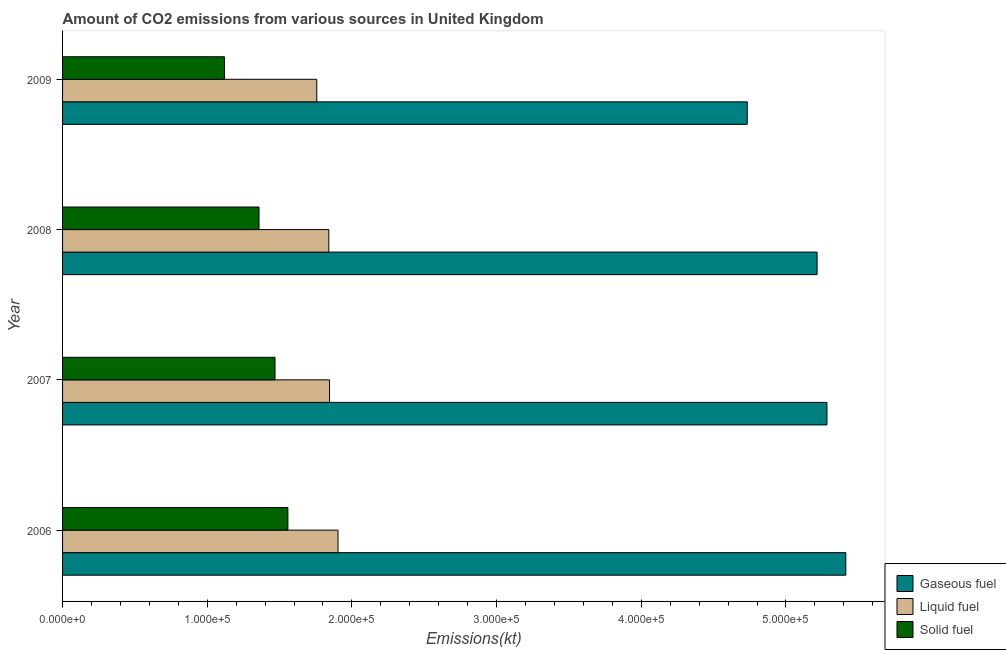How many bars are there on the 2nd tick from the top?
Give a very brief answer. 3. What is the label of the 1st group of bars from the top?
Your answer should be compact. 2009. In how many cases, is the number of bars for a given year not equal to the number of legend labels?
Ensure brevity in your answer.  0. What is the amount of co2 emissions from solid fuel in 2006?
Your answer should be compact. 1.56e+05. Across all years, what is the maximum amount of co2 emissions from gaseous fuel?
Offer a very short reply. 5.41e+05. Across all years, what is the minimum amount of co2 emissions from solid fuel?
Your answer should be compact. 1.12e+05. In which year was the amount of co2 emissions from solid fuel maximum?
Provide a succinct answer. 2006. What is the total amount of co2 emissions from gaseous fuel in the graph?
Provide a short and direct response. 2.06e+06. What is the difference between the amount of co2 emissions from liquid fuel in 2006 and that in 2007?
Your response must be concise. 5859.87. What is the difference between the amount of co2 emissions from gaseous fuel in 2006 and the amount of co2 emissions from liquid fuel in 2008?
Your answer should be very brief. 3.57e+05. What is the average amount of co2 emissions from solid fuel per year?
Your answer should be very brief. 1.38e+05. In the year 2007, what is the difference between the amount of co2 emissions from gaseous fuel and amount of co2 emissions from liquid fuel?
Make the answer very short. 3.44e+05. In how many years, is the amount of co2 emissions from gaseous fuel greater than 40000 kt?
Provide a succinct answer. 4. What is the ratio of the amount of co2 emissions from solid fuel in 2007 to that in 2009?
Offer a terse response. 1.31. Is the difference between the amount of co2 emissions from gaseous fuel in 2006 and 2007 greater than the difference between the amount of co2 emissions from liquid fuel in 2006 and 2007?
Keep it short and to the point. Yes. What is the difference between the highest and the second highest amount of co2 emissions from liquid fuel?
Your answer should be very brief. 5859.87. What is the difference between the highest and the lowest amount of co2 emissions from liquid fuel?
Make the answer very short. 1.47e+04. What does the 1st bar from the top in 2007 represents?
Give a very brief answer. Solid fuel. What does the 2nd bar from the bottom in 2008 represents?
Provide a short and direct response. Liquid fuel. Is it the case that in every year, the sum of the amount of co2 emissions from gaseous fuel and amount of co2 emissions from liquid fuel is greater than the amount of co2 emissions from solid fuel?
Provide a short and direct response. Yes. How many bars are there?
Make the answer very short. 12. How many years are there in the graph?
Your response must be concise. 4. Are the values on the major ticks of X-axis written in scientific E-notation?
Provide a succinct answer. Yes. Does the graph contain any zero values?
Offer a terse response. No. Where does the legend appear in the graph?
Give a very brief answer. Bottom right. What is the title of the graph?
Give a very brief answer. Amount of CO2 emissions from various sources in United Kingdom. Does "Ages 65 and above" appear as one of the legend labels in the graph?
Ensure brevity in your answer.  No. What is the label or title of the X-axis?
Offer a terse response. Emissions(kt). What is the label or title of the Y-axis?
Offer a very short reply. Year. What is the Emissions(kt) in Gaseous fuel in 2006?
Provide a short and direct response. 5.41e+05. What is the Emissions(kt) of Liquid fuel in 2006?
Keep it short and to the point. 1.90e+05. What is the Emissions(kt) of Solid fuel in 2006?
Give a very brief answer. 1.56e+05. What is the Emissions(kt) in Gaseous fuel in 2007?
Your response must be concise. 5.28e+05. What is the Emissions(kt) in Liquid fuel in 2007?
Your answer should be very brief. 1.85e+05. What is the Emissions(kt) of Solid fuel in 2007?
Ensure brevity in your answer.  1.47e+05. What is the Emissions(kt) of Gaseous fuel in 2008?
Offer a very short reply. 5.22e+05. What is the Emissions(kt) of Liquid fuel in 2008?
Offer a very short reply. 1.84e+05. What is the Emissions(kt) of Solid fuel in 2008?
Make the answer very short. 1.36e+05. What is the Emissions(kt) in Gaseous fuel in 2009?
Offer a terse response. 4.73e+05. What is the Emissions(kt) in Liquid fuel in 2009?
Offer a very short reply. 1.76e+05. What is the Emissions(kt) of Solid fuel in 2009?
Make the answer very short. 1.12e+05. Across all years, what is the maximum Emissions(kt) in Gaseous fuel?
Offer a very short reply. 5.41e+05. Across all years, what is the maximum Emissions(kt) of Liquid fuel?
Your answer should be compact. 1.90e+05. Across all years, what is the maximum Emissions(kt) of Solid fuel?
Your response must be concise. 1.56e+05. Across all years, what is the minimum Emissions(kt) of Gaseous fuel?
Provide a short and direct response. 4.73e+05. Across all years, what is the minimum Emissions(kt) of Liquid fuel?
Give a very brief answer. 1.76e+05. Across all years, what is the minimum Emissions(kt) of Solid fuel?
Your answer should be compact. 1.12e+05. What is the total Emissions(kt) of Gaseous fuel in the graph?
Give a very brief answer. 2.06e+06. What is the total Emissions(kt) in Liquid fuel in the graph?
Make the answer very short. 7.35e+05. What is the total Emissions(kt) in Solid fuel in the graph?
Provide a succinct answer. 5.50e+05. What is the difference between the Emissions(kt) in Gaseous fuel in 2006 and that in 2007?
Provide a succinct answer. 1.31e+04. What is the difference between the Emissions(kt) of Liquid fuel in 2006 and that in 2007?
Your answer should be very brief. 5859.87. What is the difference between the Emissions(kt) in Solid fuel in 2006 and that in 2007?
Ensure brevity in your answer.  8892.48. What is the difference between the Emissions(kt) in Gaseous fuel in 2006 and that in 2008?
Make the answer very short. 1.99e+04. What is the difference between the Emissions(kt) of Liquid fuel in 2006 and that in 2008?
Offer a very short reply. 6351.24. What is the difference between the Emissions(kt) of Solid fuel in 2006 and that in 2008?
Ensure brevity in your answer.  1.99e+04. What is the difference between the Emissions(kt) in Gaseous fuel in 2006 and that in 2009?
Make the answer very short. 6.81e+04. What is the difference between the Emissions(kt) of Liquid fuel in 2006 and that in 2009?
Your response must be concise. 1.47e+04. What is the difference between the Emissions(kt) in Solid fuel in 2006 and that in 2009?
Give a very brief answer. 4.39e+04. What is the difference between the Emissions(kt) of Gaseous fuel in 2007 and that in 2008?
Your answer should be compact. 6809.62. What is the difference between the Emissions(kt) of Liquid fuel in 2007 and that in 2008?
Provide a short and direct response. 491.38. What is the difference between the Emissions(kt) of Solid fuel in 2007 and that in 2008?
Your response must be concise. 1.10e+04. What is the difference between the Emissions(kt) of Gaseous fuel in 2007 and that in 2009?
Your answer should be compact. 5.51e+04. What is the difference between the Emissions(kt) in Liquid fuel in 2007 and that in 2009?
Make the answer very short. 8826.47. What is the difference between the Emissions(kt) of Solid fuel in 2007 and that in 2009?
Give a very brief answer. 3.50e+04. What is the difference between the Emissions(kt) of Gaseous fuel in 2008 and that in 2009?
Make the answer very short. 4.83e+04. What is the difference between the Emissions(kt) of Liquid fuel in 2008 and that in 2009?
Your response must be concise. 8335.09. What is the difference between the Emissions(kt) in Solid fuel in 2008 and that in 2009?
Ensure brevity in your answer.  2.39e+04. What is the difference between the Emissions(kt) in Gaseous fuel in 2006 and the Emissions(kt) in Liquid fuel in 2007?
Provide a succinct answer. 3.57e+05. What is the difference between the Emissions(kt) of Gaseous fuel in 2006 and the Emissions(kt) of Solid fuel in 2007?
Offer a terse response. 3.95e+05. What is the difference between the Emissions(kt) in Liquid fuel in 2006 and the Emissions(kt) in Solid fuel in 2007?
Ensure brevity in your answer.  4.35e+04. What is the difference between the Emissions(kt) in Gaseous fuel in 2006 and the Emissions(kt) in Liquid fuel in 2008?
Ensure brevity in your answer.  3.57e+05. What is the difference between the Emissions(kt) of Gaseous fuel in 2006 and the Emissions(kt) of Solid fuel in 2008?
Offer a very short reply. 4.06e+05. What is the difference between the Emissions(kt) in Liquid fuel in 2006 and the Emissions(kt) in Solid fuel in 2008?
Ensure brevity in your answer.  5.46e+04. What is the difference between the Emissions(kt) of Gaseous fuel in 2006 and the Emissions(kt) of Liquid fuel in 2009?
Your response must be concise. 3.66e+05. What is the difference between the Emissions(kt) of Gaseous fuel in 2006 and the Emissions(kt) of Solid fuel in 2009?
Keep it short and to the point. 4.29e+05. What is the difference between the Emissions(kt) of Liquid fuel in 2006 and the Emissions(kt) of Solid fuel in 2009?
Keep it short and to the point. 7.85e+04. What is the difference between the Emissions(kt) of Gaseous fuel in 2007 and the Emissions(kt) of Liquid fuel in 2008?
Provide a succinct answer. 3.44e+05. What is the difference between the Emissions(kt) of Gaseous fuel in 2007 and the Emissions(kt) of Solid fuel in 2008?
Keep it short and to the point. 3.93e+05. What is the difference between the Emissions(kt) of Liquid fuel in 2007 and the Emissions(kt) of Solid fuel in 2008?
Your response must be concise. 4.87e+04. What is the difference between the Emissions(kt) of Gaseous fuel in 2007 and the Emissions(kt) of Liquid fuel in 2009?
Offer a terse response. 3.53e+05. What is the difference between the Emissions(kt) in Gaseous fuel in 2007 and the Emissions(kt) in Solid fuel in 2009?
Make the answer very short. 4.16e+05. What is the difference between the Emissions(kt) of Liquid fuel in 2007 and the Emissions(kt) of Solid fuel in 2009?
Keep it short and to the point. 7.26e+04. What is the difference between the Emissions(kt) in Gaseous fuel in 2008 and the Emissions(kt) in Liquid fuel in 2009?
Your response must be concise. 3.46e+05. What is the difference between the Emissions(kt) of Gaseous fuel in 2008 and the Emissions(kt) of Solid fuel in 2009?
Offer a terse response. 4.10e+05. What is the difference between the Emissions(kt) in Liquid fuel in 2008 and the Emissions(kt) in Solid fuel in 2009?
Ensure brevity in your answer.  7.21e+04. What is the average Emissions(kt) of Gaseous fuel per year?
Your answer should be very brief. 5.16e+05. What is the average Emissions(kt) of Liquid fuel per year?
Provide a short and direct response. 1.84e+05. What is the average Emissions(kt) of Solid fuel per year?
Your answer should be very brief. 1.38e+05. In the year 2006, what is the difference between the Emissions(kt) of Gaseous fuel and Emissions(kt) of Liquid fuel?
Provide a short and direct response. 3.51e+05. In the year 2006, what is the difference between the Emissions(kt) in Gaseous fuel and Emissions(kt) in Solid fuel?
Make the answer very short. 3.86e+05. In the year 2006, what is the difference between the Emissions(kt) in Liquid fuel and Emissions(kt) in Solid fuel?
Provide a succinct answer. 3.46e+04. In the year 2007, what is the difference between the Emissions(kt) of Gaseous fuel and Emissions(kt) of Liquid fuel?
Your answer should be compact. 3.44e+05. In the year 2007, what is the difference between the Emissions(kt) of Gaseous fuel and Emissions(kt) of Solid fuel?
Provide a succinct answer. 3.81e+05. In the year 2007, what is the difference between the Emissions(kt) of Liquid fuel and Emissions(kt) of Solid fuel?
Provide a succinct answer. 3.77e+04. In the year 2008, what is the difference between the Emissions(kt) of Gaseous fuel and Emissions(kt) of Liquid fuel?
Offer a very short reply. 3.37e+05. In the year 2008, what is the difference between the Emissions(kt) of Gaseous fuel and Emissions(kt) of Solid fuel?
Provide a short and direct response. 3.86e+05. In the year 2008, what is the difference between the Emissions(kt) of Liquid fuel and Emissions(kt) of Solid fuel?
Ensure brevity in your answer.  4.82e+04. In the year 2009, what is the difference between the Emissions(kt) in Gaseous fuel and Emissions(kt) in Liquid fuel?
Provide a succinct answer. 2.98e+05. In the year 2009, what is the difference between the Emissions(kt) of Gaseous fuel and Emissions(kt) of Solid fuel?
Offer a terse response. 3.61e+05. In the year 2009, what is the difference between the Emissions(kt) in Liquid fuel and Emissions(kt) in Solid fuel?
Provide a short and direct response. 6.38e+04. What is the ratio of the Emissions(kt) of Gaseous fuel in 2006 to that in 2007?
Offer a very short reply. 1.02. What is the ratio of the Emissions(kt) of Liquid fuel in 2006 to that in 2007?
Make the answer very short. 1.03. What is the ratio of the Emissions(kt) in Solid fuel in 2006 to that in 2007?
Provide a short and direct response. 1.06. What is the ratio of the Emissions(kt) in Gaseous fuel in 2006 to that in 2008?
Make the answer very short. 1.04. What is the ratio of the Emissions(kt) of Liquid fuel in 2006 to that in 2008?
Offer a terse response. 1.03. What is the ratio of the Emissions(kt) of Solid fuel in 2006 to that in 2008?
Give a very brief answer. 1.15. What is the ratio of the Emissions(kt) of Gaseous fuel in 2006 to that in 2009?
Your answer should be very brief. 1.14. What is the ratio of the Emissions(kt) of Liquid fuel in 2006 to that in 2009?
Provide a short and direct response. 1.08. What is the ratio of the Emissions(kt) in Solid fuel in 2006 to that in 2009?
Give a very brief answer. 1.39. What is the ratio of the Emissions(kt) in Gaseous fuel in 2007 to that in 2008?
Your answer should be compact. 1.01. What is the ratio of the Emissions(kt) in Solid fuel in 2007 to that in 2008?
Your response must be concise. 1.08. What is the ratio of the Emissions(kt) of Gaseous fuel in 2007 to that in 2009?
Your answer should be compact. 1.12. What is the ratio of the Emissions(kt) of Liquid fuel in 2007 to that in 2009?
Give a very brief answer. 1.05. What is the ratio of the Emissions(kt) in Solid fuel in 2007 to that in 2009?
Keep it short and to the point. 1.31. What is the ratio of the Emissions(kt) of Gaseous fuel in 2008 to that in 2009?
Make the answer very short. 1.1. What is the ratio of the Emissions(kt) in Liquid fuel in 2008 to that in 2009?
Keep it short and to the point. 1.05. What is the ratio of the Emissions(kt) in Solid fuel in 2008 to that in 2009?
Provide a succinct answer. 1.21. What is the difference between the highest and the second highest Emissions(kt) of Gaseous fuel?
Provide a short and direct response. 1.31e+04. What is the difference between the highest and the second highest Emissions(kt) of Liquid fuel?
Your answer should be compact. 5859.87. What is the difference between the highest and the second highest Emissions(kt) in Solid fuel?
Ensure brevity in your answer.  8892.48. What is the difference between the highest and the lowest Emissions(kt) in Gaseous fuel?
Give a very brief answer. 6.81e+04. What is the difference between the highest and the lowest Emissions(kt) of Liquid fuel?
Provide a short and direct response. 1.47e+04. What is the difference between the highest and the lowest Emissions(kt) in Solid fuel?
Make the answer very short. 4.39e+04. 